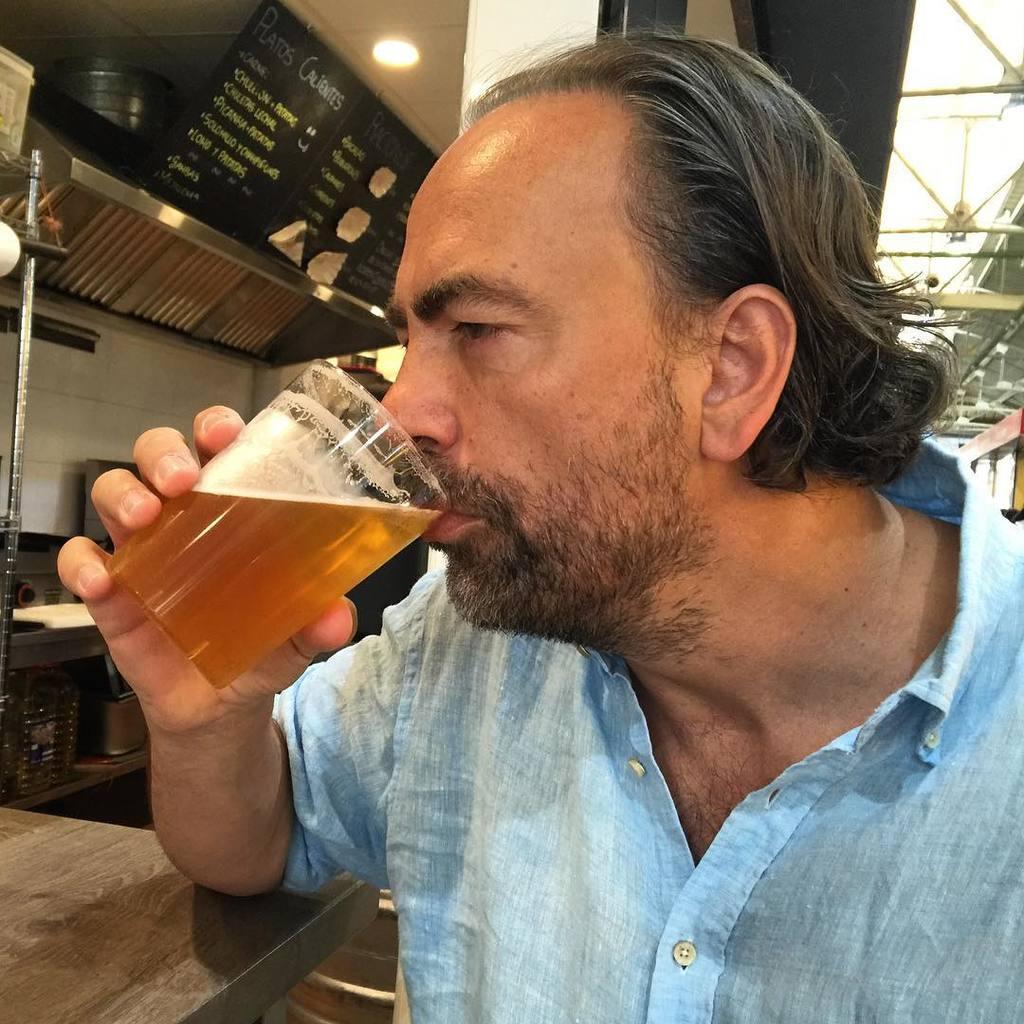Can you describe this image briefly? In this image we can see a man holding a glass and drinking. At the back side we can see some vessels. 